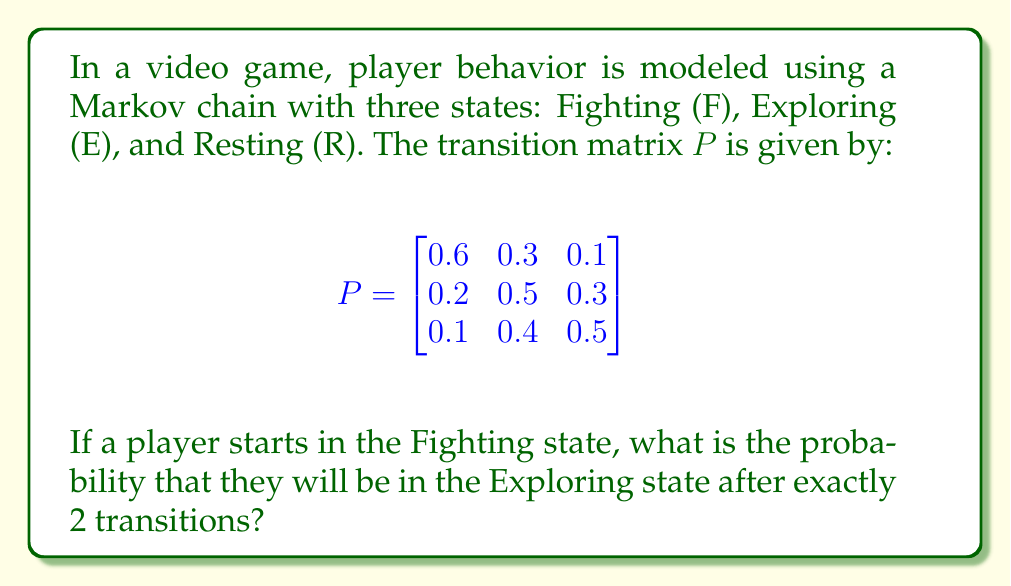Give your solution to this math problem. To solve this problem, we need to use the properties of Markov chains and matrix multiplication. Let's approach this step-by-step:

1) The initial state vector is $\vec{v}_0 = \begin{bmatrix} 1 & 0 & 0 \end{bmatrix}$, representing that the player starts in the Fighting state.

2) To find the state after 2 transitions, we need to multiply the initial state vector by the transition matrix twice:

   $\vec{v}_2 = \vec{v}_0 \cdot P^2$

3) First, let's calculate $P^2$:

   $$P^2 = P \cdot P = \begin{bmatrix}
   0.6 & 0.3 & 0.1 \\
   0.2 & 0.5 & 0.3 \\
   0.1 & 0.4 & 0.5
   \end{bmatrix} \cdot \begin{bmatrix}
   0.6 & 0.3 & 0.1 \\
   0.2 & 0.5 & 0.3 \\
   0.1 & 0.4 & 0.5
   \end{bmatrix}$$

4) Performing the matrix multiplication:

   $$P^2 = \begin{bmatrix}
   0.42 & 0.39 & 0.19 \\
   0.23 & 0.46 & 0.31 \\
   0.17 & 0.44 & 0.39
   \end{bmatrix}$$

5) Now, we multiply the initial state vector by $P^2$:

   $\vec{v}_2 = \begin{bmatrix} 1 & 0 & 0 \end{bmatrix} \cdot \begin{bmatrix}
   0.42 & 0.39 & 0.19 \\
   0.23 & 0.46 & 0.31 \\
   0.17 & 0.44 & 0.39
   \end{bmatrix}$

6) This multiplication results in:

   $\vec{v}_2 = \begin{bmatrix} 0.42 & 0.39 & 0.19 \end{bmatrix}$

7) The probability of being in the Exploring state (the second state) after 2 transitions is the second element of this vector: 0.39 or 39%.
Answer: 0.39 